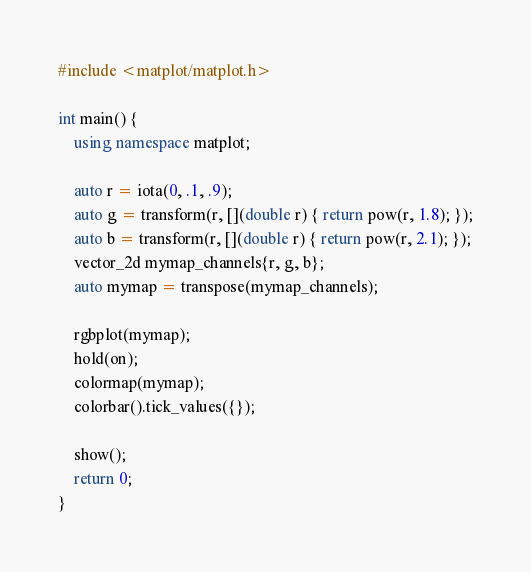Convert code to text. <code><loc_0><loc_0><loc_500><loc_500><_C++_>#include <matplot/matplot.h>

int main() {
    using namespace matplot;

    auto r = iota(0, .1, .9);
    auto g = transform(r, [](double r) { return pow(r, 1.8); });
    auto b = transform(r, [](double r) { return pow(r, 2.1); });
    vector_2d mymap_channels{r, g, b};
    auto mymap = transpose(mymap_channels);

    rgbplot(mymap);
    hold(on);
    colormap(mymap);
    colorbar().tick_values({});

    show();
    return 0;
}</code> 